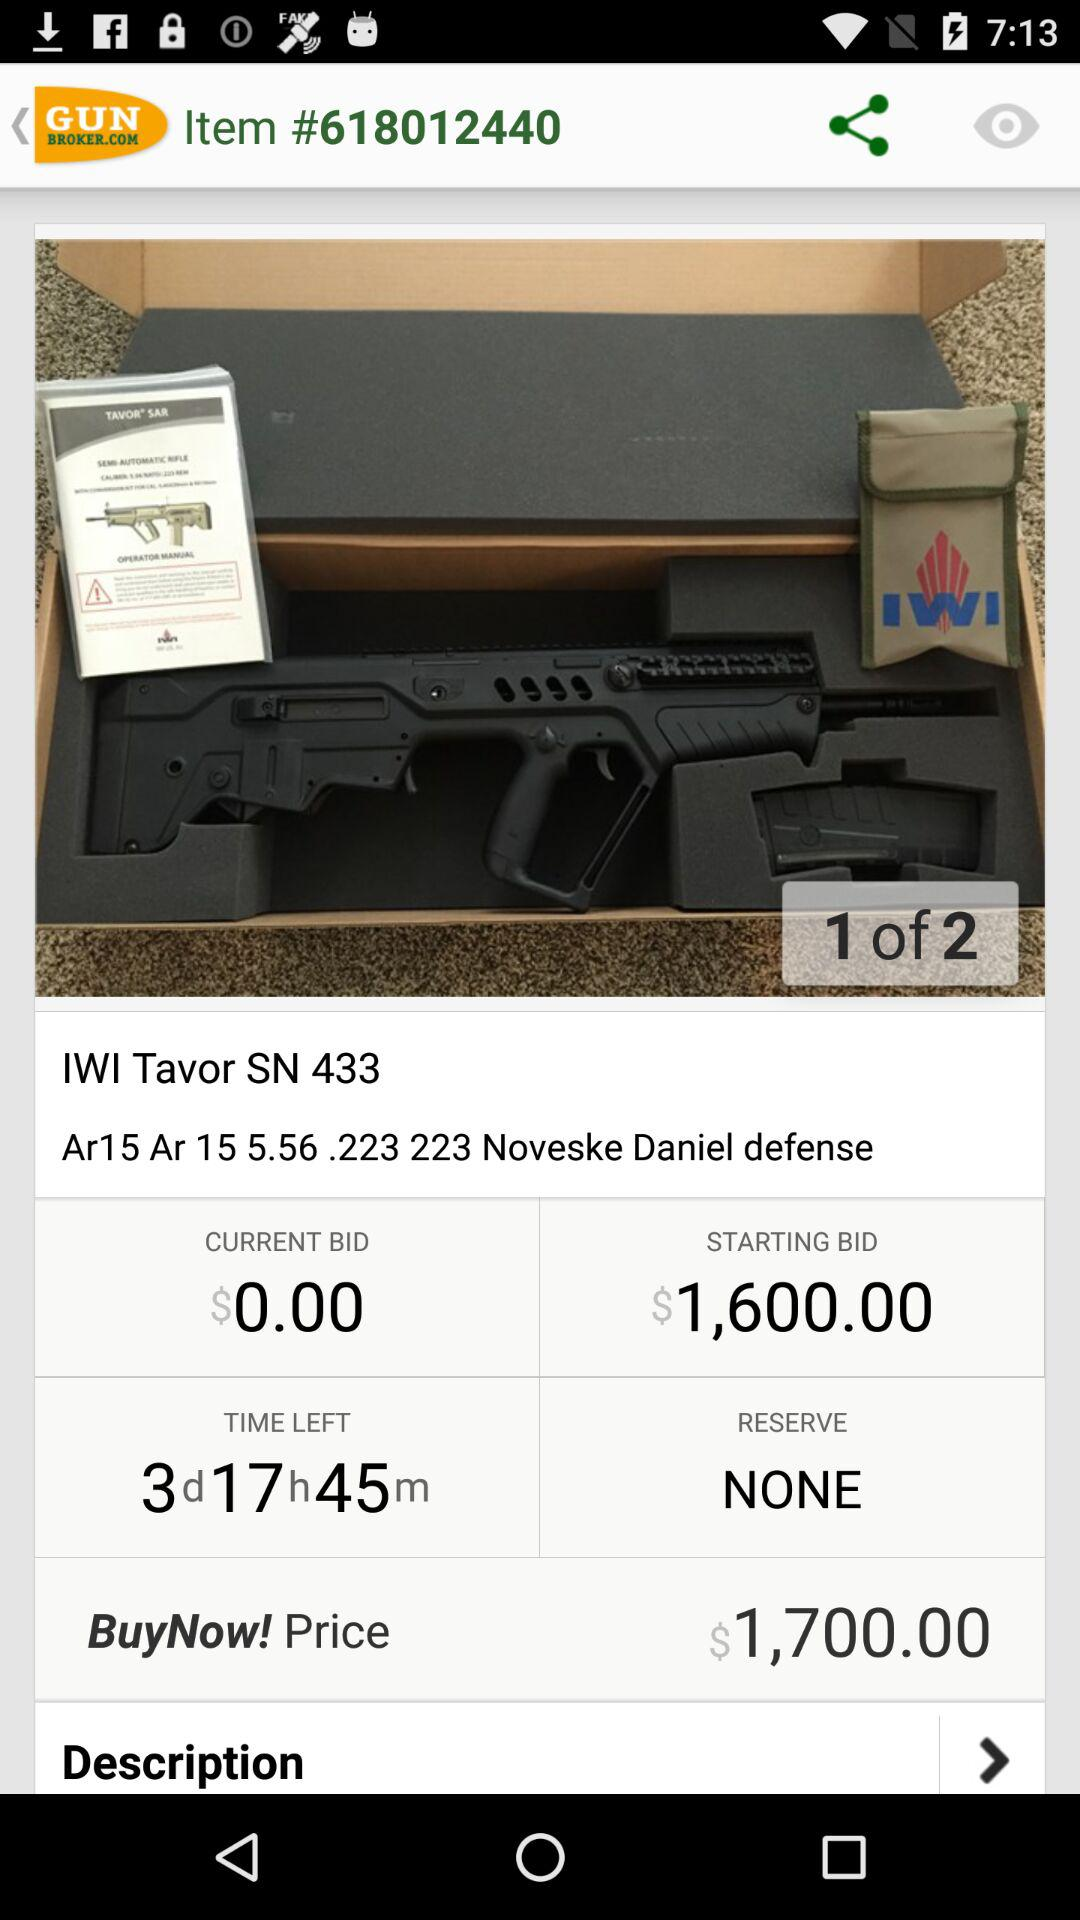What is mentioned in "RESERVE"? In "RESERVE", "NONE" is mentioned. 